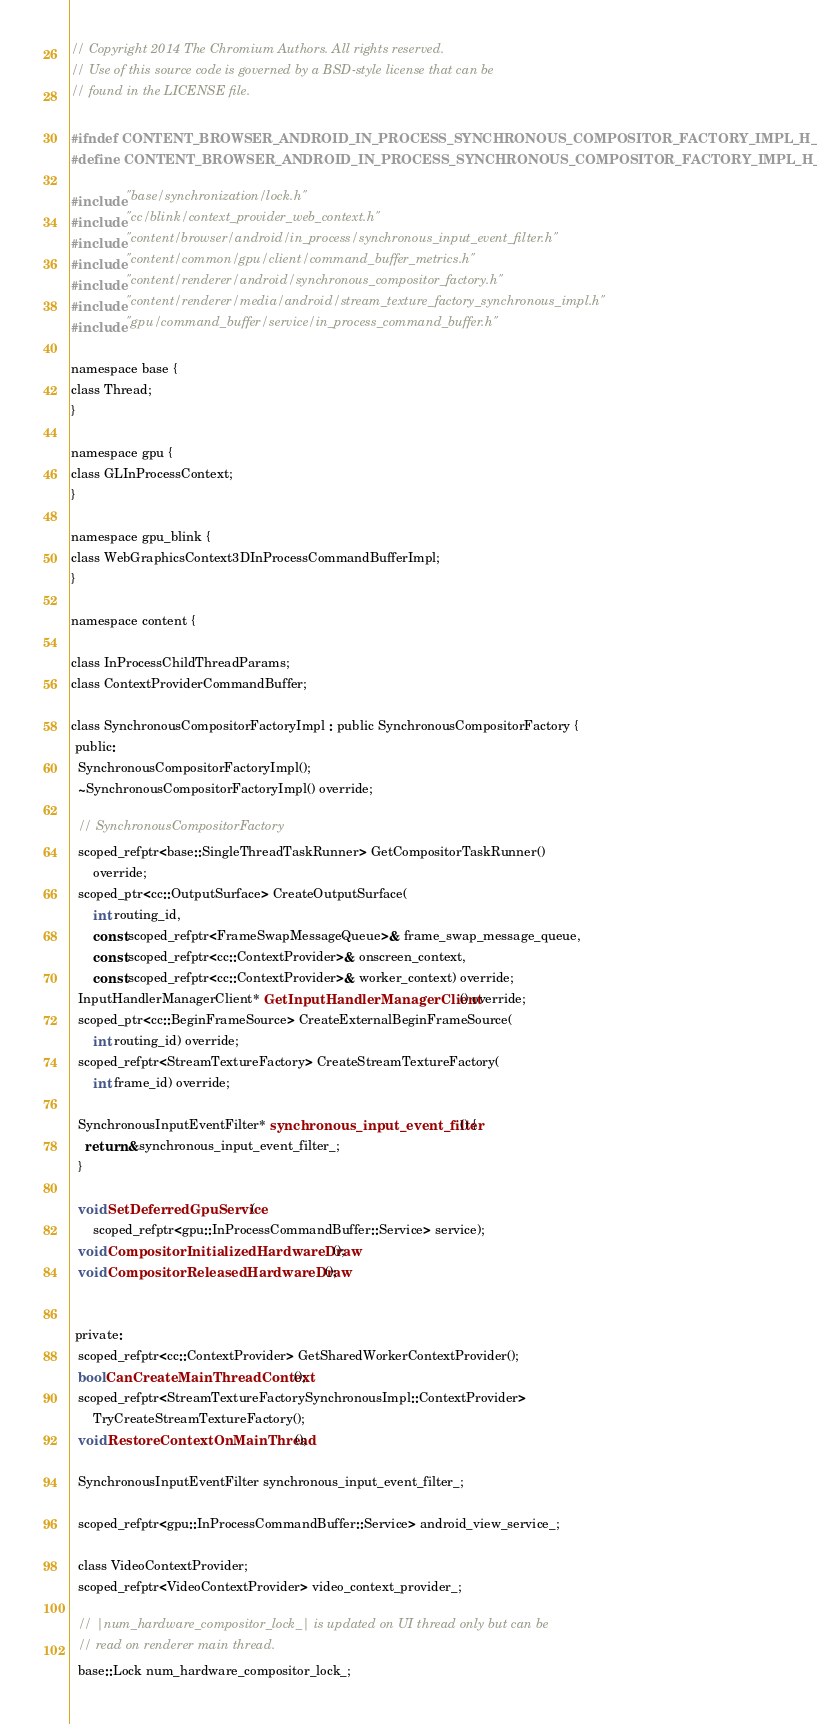Convert code to text. <code><loc_0><loc_0><loc_500><loc_500><_C_>// Copyright 2014 The Chromium Authors. All rights reserved.
// Use of this source code is governed by a BSD-style license that can be
// found in the LICENSE file.

#ifndef CONTENT_BROWSER_ANDROID_IN_PROCESS_SYNCHRONOUS_COMPOSITOR_FACTORY_IMPL_H_
#define CONTENT_BROWSER_ANDROID_IN_PROCESS_SYNCHRONOUS_COMPOSITOR_FACTORY_IMPL_H_

#include "base/synchronization/lock.h"
#include "cc/blink/context_provider_web_context.h"
#include "content/browser/android/in_process/synchronous_input_event_filter.h"
#include "content/common/gpu/client/command_buffer_metrics.h"
#include "content/renderer/android/synchronous_compositor_factory.h"
#include "content/renderer/media/android/stream_texture_factory_synchronous_impl.h"
#include "gpu/command_buffer/service/in_process_command_buffer.h"

namespace base {
class Thread;
}

namespace gpu {
class GLInProcessContext;
}

namespace gpu_blink {
class WebGraphicsContext3DInProcessCommandBufferImpl;
}

namespace content {

class InProcessChildThreadParams;
class ContextProviderCommandBuffer;

class SynchronousCompositorFactoryImpl : public SynchronousCompositorFactory {
 public:
  SynchronousCompositorFactoryImpl();
  ~SynchronousCompositorFactoryImpl() override;

  // SynchronousCompositorFactory
  scoped_refptr<base::SingleThreadTaskRunner> GetCompositorTaskRunner()
      override;
  scoped_ptr<cc::OutputSurface> CreateOutputSurface(
      int routing_id,
      const scoped_refptr<FrameSwapMessageQueue>& frame_swap_message_queue,
      const scoped_refptr<cc::ContextProvider>& onscreen_context,
      const scoped_refptr<cc::ContextProvider>& worker_context) override;
  InputHandlerManagerClient* GetInputHandlerManagerClient() override;
  scoped_ptr<cc::BeginFrameSource> CreateExternalBeginFrameSource(
      int routing_id) override;
  scoped_refptr<StreamTextureFactory> CreateStreamTextureFactory(
      int frame_id) override;

  SynchronousInputEventFilter* synchronous_input_event_filter() {
    return &synchronous_input_event_filter_;
  }

  void SetDeferredGpuService(
      scoped_refptr<gpu::InProcessCommandBuffer::Service> service);
  void CompositorInitializedHardwareDraw();
  void CompositorReleasedHardwareDraw();


 private:
  scoped_refptr<cc::ContextProvider> GetSharedWorkerContextProvider();
  bool CanCreateMainThreadContext();
  scoped_refptr<StreamTextureFactorySynchronousImpl::ContextProvider>
      TryCreateStreamTextureFactory();
  void RestoreContextOnMainThread();

  SynchronousInputEventFilter synchronous_input_event_filter_;

  scoped_refptr<gpu::InProcessCommandBuffer::Service> android_view_service_;

  class VideoContextProvider;
  scoped_refptr<VideoContextProvider> video_context_provider_;

  // |num_hardware_compositor_lock_| is updated on UI thread only but can be
  // read on renderer main thread.
  base::Lock num_hardware_compositor_lock_;</code> 